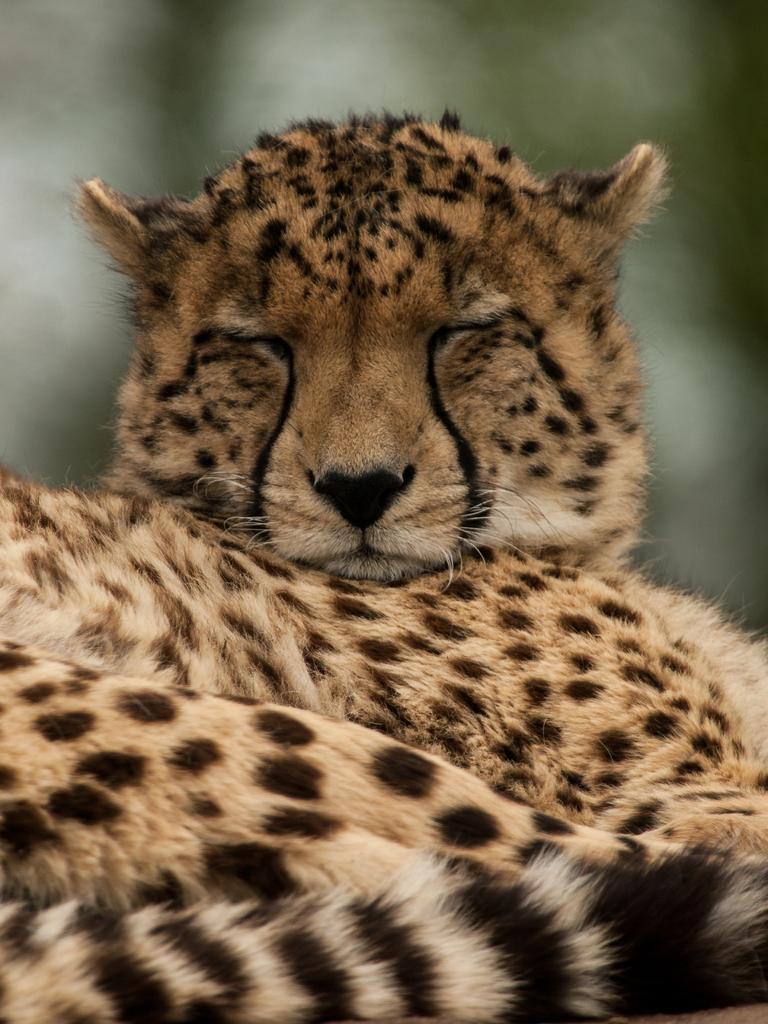How would you summarize this image in a sentence or two? In this image in the foreground there is a tiger, background is blurry. 